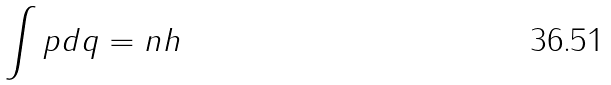Convert formula to latex. <formula><loc_0><loc_0><loc_500><loc_500>\int p d q = n h</formula> 